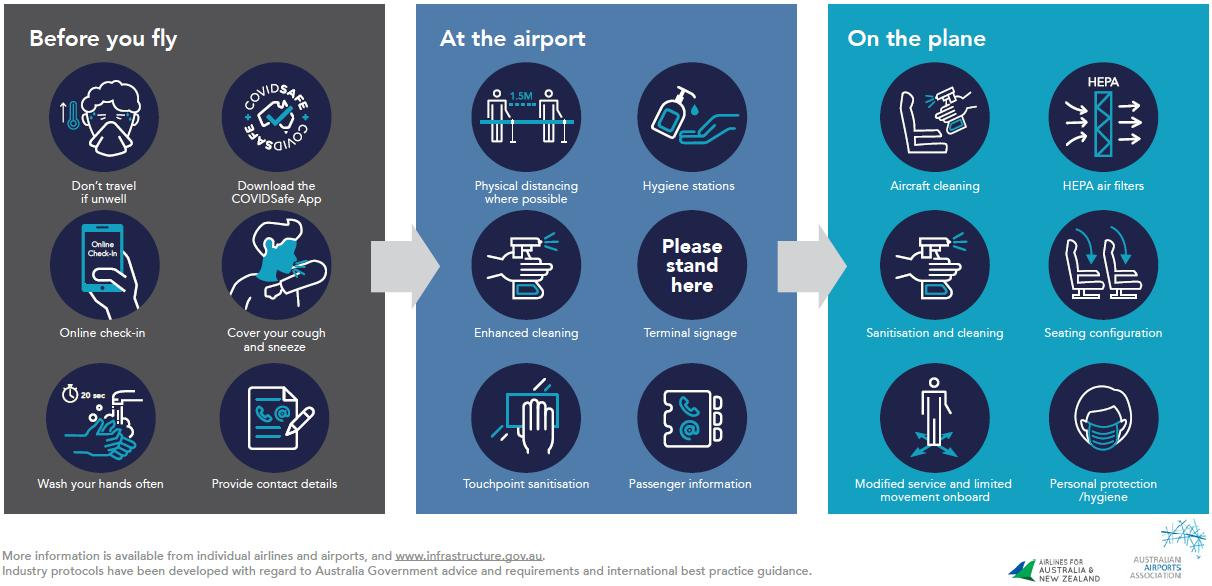Highlight a few significant elements in this photo. Before taking off, there are six steps that must be followed. The HEPA air filters are typically found on airplanes. Touchpoint sanitization is important at airports, as they serve as a critical point of entry and exit for individuals and goods entering and leaving a country. Please stand here, as your journey is about to begin. At the airport, you will be greeted by our friendly staff who will guide you through the check-in process. The icon for enhanced cleaning is the same as the icon for sanitization and cleaning. 